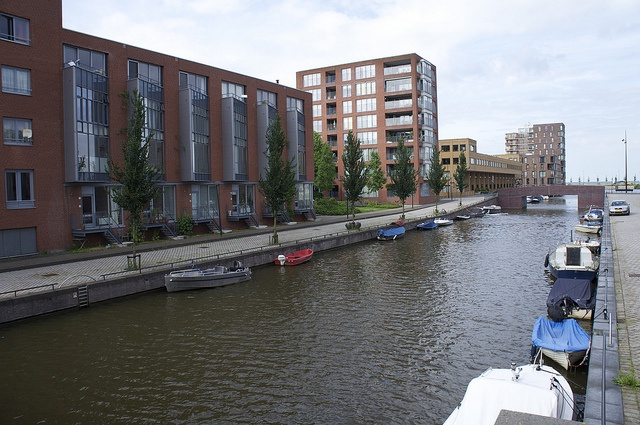Describe the objects in this image and their specific colors. I can see boat in black, white, darkgray, and gray tones, boat in black, darkgray, and lightblue tones, boat in black and gray tones, boat in black, gray, and darkblue tones, and boat in black, lightgray, and darkgray tones in this image. 